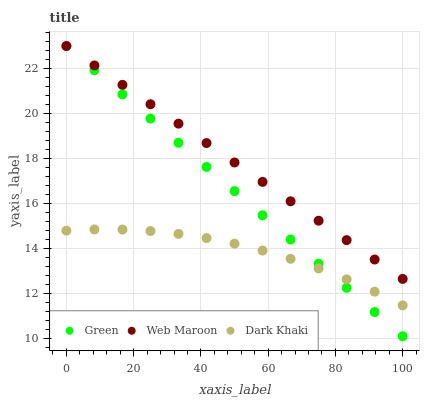Does Dark Khaki have the minimum area under the curve?
Answer yes or no. Yes. Does Web Maroon have the maximum area under the curve?
Answer yes or no. Yes. Does Green have the minimum area under the curve?
Answer yes or no. No. Does Green have the maximum area under the curve?
Answer yes or no. No. Is Green the smoothest?
Answer yes or no. Yes. Is Dark Khaki the roughest?
Answer yes or no. Yes. Is Web Maroon the smoothest?
Answer yes or no. No. Is Web Maroon the roughest?
Answer yes or no. No. Does Green have the lowest value?
Answer yes or no. Yes. Does Web Maroon have the lowest value?
Answer yes or no. No. Does Green have the highest value?
Answer yes or no. Yes. Is Dark Khaki less than Web Maroon?
Answer yes or no. Yes. Is Web Maroon greater than Dark Khaki?
Answer yes or no. Yes. Does Web Maroon intersect Green?
Answer yes or no. Yes. Is Web Maroon less than Green?
Answer yes or no. No. Is Web Maroon greater than Green?
Answer yes or no. No. Does Dark Khaki intersect Web Maroon?
Answer yes or no. No. 